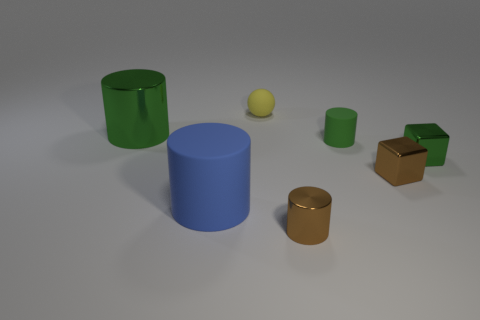What is the color of the shiny cylinder that is to the left of the big thing on the right side of the metallic cylinder behind the tiny green shiny cube?
Ensure brevity in your answer.  Green. Are there any brown things that have the same shape as the small green rubber thing?
Your answer should be compact. Yes. What number of gray matte objects are there?
Your response must be concise. 0. There is a big rubber object; what shape is it?
Make the answer very short. Cylinder. How many brown shiny cylinders have the same size as the rubber sphere?
Give a very brief answer. 1. Is the tiny yellow thing the same shape as the big blue thing?
Your answer should be compact. No. What is the color of the tiny matte object behind the small rubber object that is in front of the matte ball?
Make the answer very short. Yellow. How big is the object that is both in front of the green shiny cube and right of the small brown metal cylinder?
Make the answer very short. Small. Is there any other thing of the same color as the small sphere?
Your answer should be very brief. No. There is a green thing that is the same material as the tiny green cube; what is its shape?
Offer a very short reply. Cylinder. 